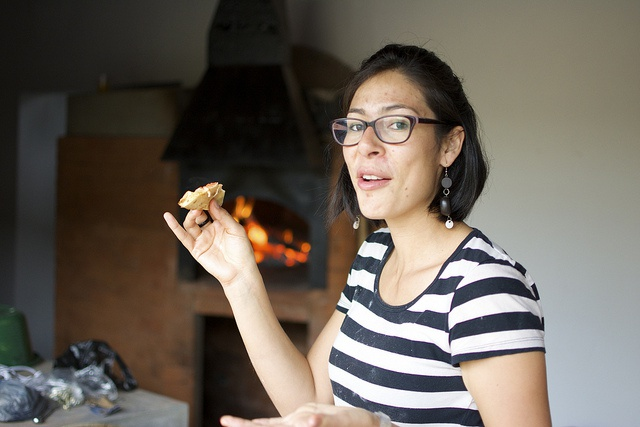Describe the objects in this image and their specific colors. I can see people in black, white, and tan tones, dining table in black and gray tones, and pizza in black, tan, and beige tones in this image. 